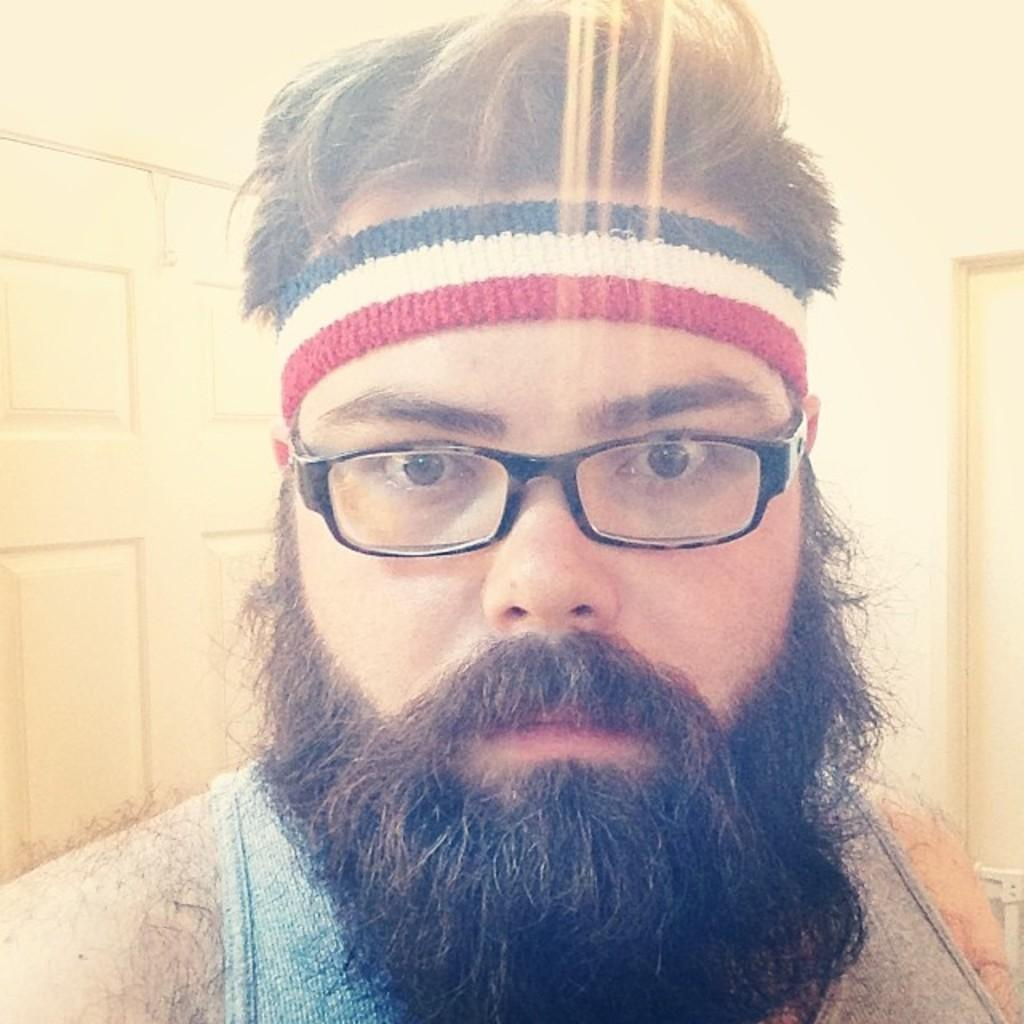Who is the main subject in the image? There is a man in the front of the image. What is the man wearing in the image? The man is wearing spectacles. What can be seen in the background of the image? There is a door in the background of the image. What type of fowl can be seen in the image? There is no fowl present in the image. What appliance is the man using in the image? The provided facts do not mention any appliances in the image. 